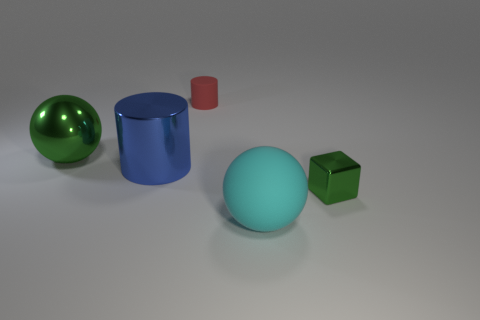Add 3 shiny objects. How many objects exist? 8 Subtract all blocks. How many objects are left? 4 Add 2 tiny green objects. How many tiny green objects are left? 3 Add 4 big green spheres. How many big green spheres exist? 5 Subtract 0 yellow cubes. How many objects are left? 5 Subtract all large gray blocks. Subtract all red objects. How many objects are left? 4 